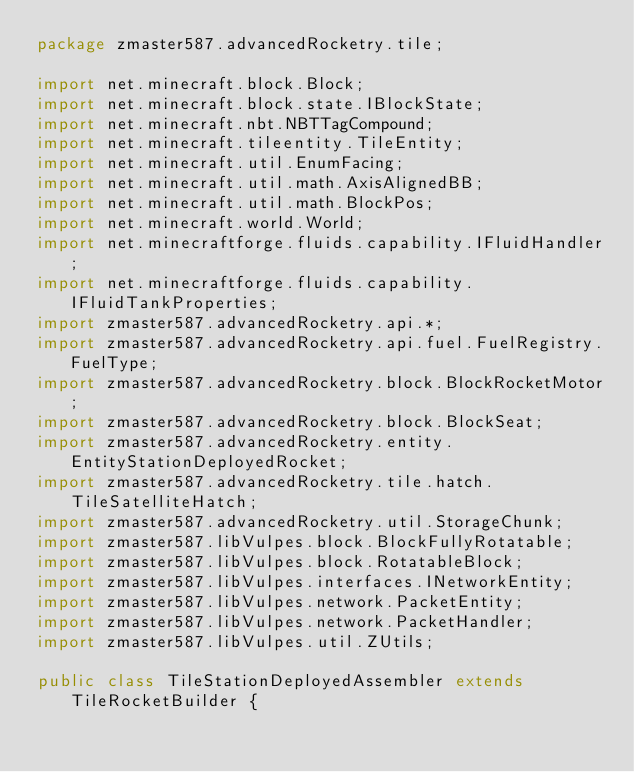Convert code to text. <code><loc_0><loc_0><loc_500><loc_500><_Java_>package zmaster587.advancedRocketry.tile;

import net.minecraft.block.Block;
import net.minecraft.block.state.IBlockState;
import net.minecraft.nbt.NBTTagCompound;
import net.minecraft.tileentity.TileEntity;
import net.minecraft.util.EnumFacing;
import net.minecraft.util.math.AxisAlignedBB;
import net.minecraft.util.math.BlockPos;
import net.minecraft.world.World;
import net.minecraftforge.fluids.capability.IFluidHandler;
import net.minecraftforge.fluids.capability.IFluidTankProperties;
import zmaster587.advancedRocketry.api.*;
import zmaster587.advancedRocketry.api.fuel.FuelRegistry.FuelType;
import zmaster587.advancedRocketry.block.BlockRocketMotor;
import zmaster587.advancedRocketry.block.BlockSeat;
import zmaster587.advancedRocketry.entity.EntityStationDeployedRocket;
import zmaster587.advancedRocketry.tile.hatch.TileSatelliteHatch;
import zmaster587.advancedRocketry.util.StorageChunk;
import zmaster587.libVulpes.block.BlockFullyRotatable;
import zmaster587.libVulpes.block.RotatableBlock;
import zmaster587.libVulpes.interfaces.INetworkEntity;
import zmaster587.libVulpes.network.PacketEntity;
import zmaster587.libVulpes.network.PacketHandler;
import zmaster587.libVulpes.util.ZUtils;

public class TileStationDeployedAssembler extends TileRocketBuilder {
</code> 